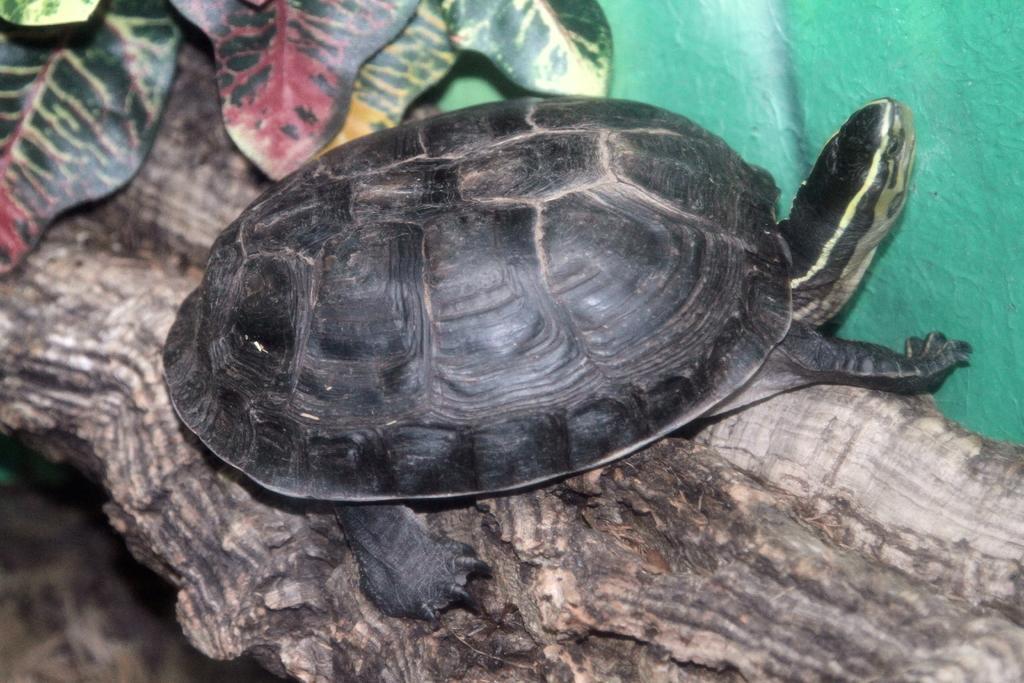Please provide a concise description of this image. In the center of the image there is a tortoise on a tree trunk. At the top of the image there are leaves. 